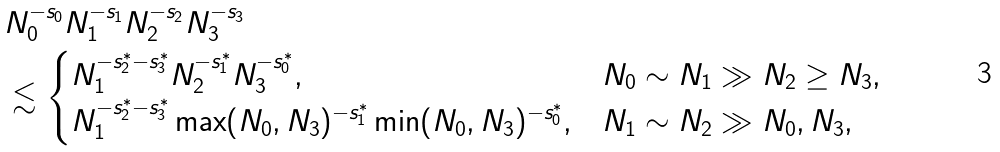<formula> <loc_0><loc_0><loc_500><loc_500>& N _ { 0 } ^ { - s _ { 0 } } N _ { 1 } ^ { - s _ { 1 } } N _ { 2 } ^ { - s _ { 2 } } N _ { 3 } ^ { - s _ { 3 } } \\ & \lesssim \begin{cases} N _ { 1 } ^ { - s _ { 2 } ^ { \ast } - s _ { 3 } ^ { \ast } } N _ { 2 } ^ { - s _ { 1 } ^ { \ast } } N _ { 3 } ^ { - s _ { 0 } ^ { \ast } } , & N _ { 0 } \sim N _ { 1 } \gg N _ { 2 } \geq N _ { 3 } , \\ N _ { 1 } ^ { - s _ { 2 } ^ { \ast } - s _ { 3 } ^ { \ast } } \max ( N _ { 0 } , N _ { 3 } ) ^ { - s _ { 1 } ^ { \ast } } \min ( N _ { 0 } , N _ { 3 } ) ^ { - s _ { 0 } ^ { \ast } } , & N _ { 1 } \sim N _ { 2 } \gg N _ { 0 } , N _ { 3 } , \end{cases}</formula> 